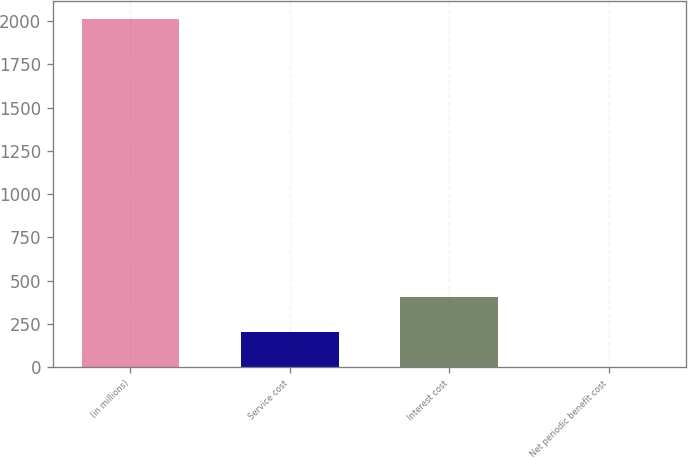Convert chart to OTSL. <chart><loc_0><loc_0><loc_500><loc_500><bar_chart><fcel>(in millions)<fcel>Service cost<fcel>Interest cost<fcel>Net periodic benefit cost<nl><fcel>2014<fcel>203.2<fcel>404.4<fcel>2<nl></chart> 